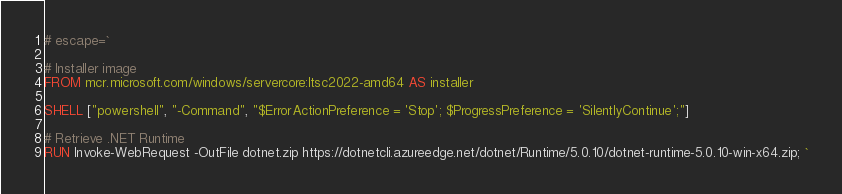Convert code to text. <code><loc_0><loc_0><loc_500><loc_500><_Dockerfile_># escape=`

# Installer image
FROM mcr.microsoft.com/windows/servercore:ltsc2022-amd64 AS installer

SHELL ["powershell", "-Command", "$ErrorActionPreference = 'Stop'; $ProgressPreference = 'SilentlyContinue';"]

# Retrieve .NET Runtime
RUN Invoke-WebRequest -OutFile dotnet.zip https://dotnetcli.azureedge.net/dotnet/Runtime/5.0.10/dotnet-runtime-5.0.10-win-x64.zip; `</code> 